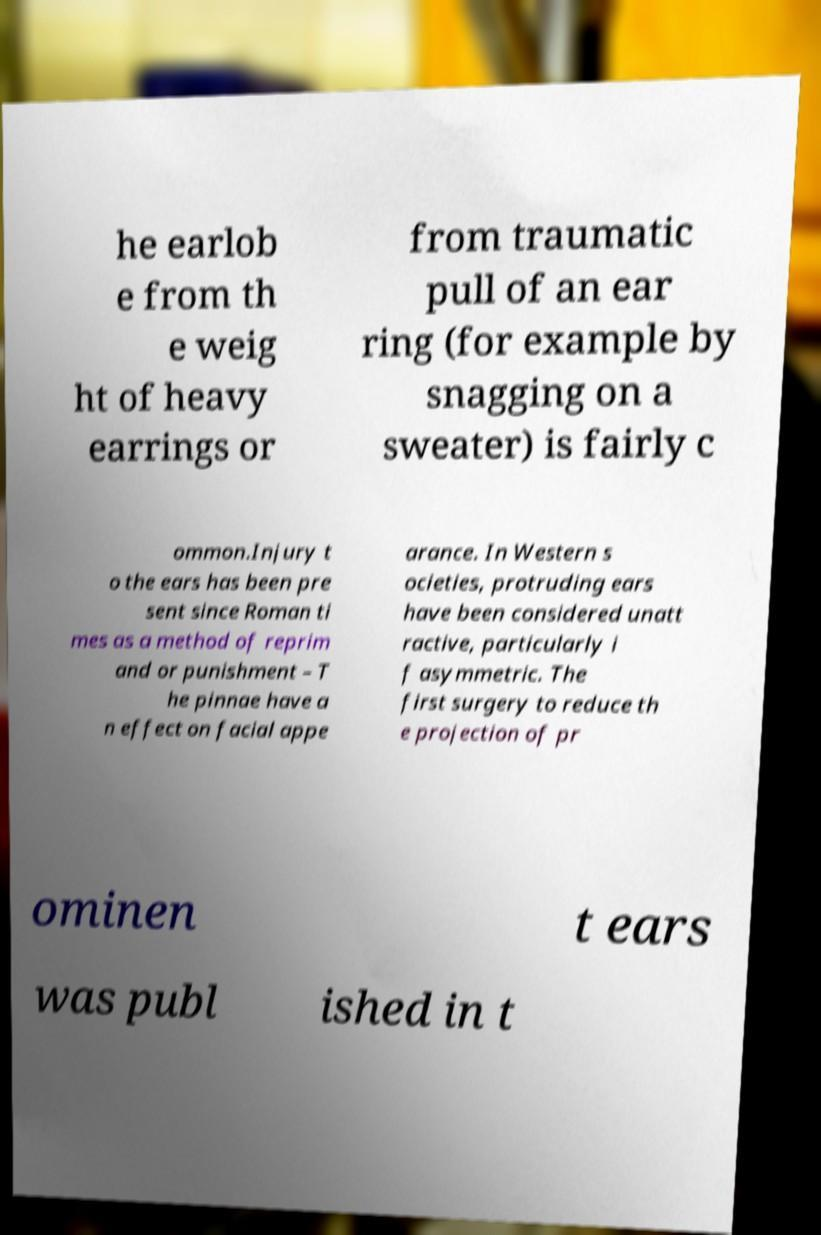Please read and relay the text visible in this image. What does it say? he earlob e from th e weig ht of heavy earrings or from traumatic pull of an ear ring (for example by snagging on a sweater) is fairly c ommon.Injury t o the ears has been pre sent since Roman ti mes as a method of reprim and or punishment – T he pinnae have a n effect on facial appe arance. In Western s ocieties, protruding ears have been considered unatt ractive, particularly i f asymmetric. The first surgery to reduce th e projection of pr ominen t ears was publ ished in t 